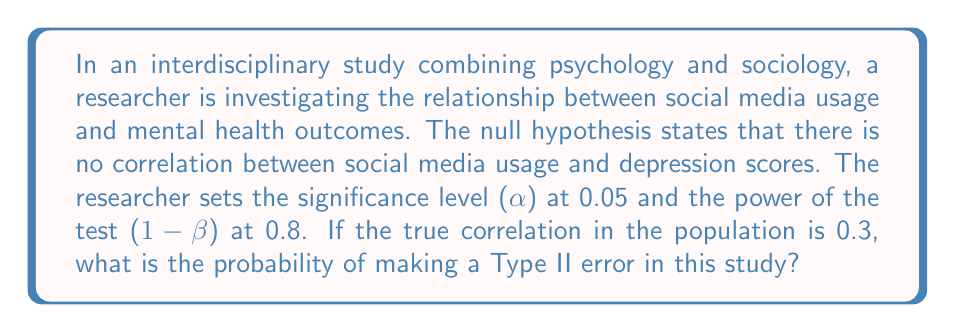Provide a solution to this math problem. To solve this problem, we need to understand the relationship between Type I error, Type II error, significance level, and power. Let's break it down step-by-step:

1. Type I error (α) is the probability of rejecting the null hypothesis when it's actually true. In this case, α = 0.05.

2. Type II error (β) is the probability of failing to reject the null hypothesis when it's actually false.

3. Power (1 - β) is the probability of correctly rejecting the null hypothesis when it's false. We're given that the power is 0.8.

4. The relationship between power and Type II error is:
   $$ \text{Power} = 1 - \beta $$

5. Given that the power is 0.8, we can calculate β:
   $$ 0.8 = 1 - \beta $$
   $$ \beta = 1 - 0.8 = 0.2 $$

6. The probability of making a Type II error is equal to β, which we just calculated as 0.2 or 20%.

Note: The actual correlation in the population (0.3) and the significance level (0.05) are not directly used in this calculation but are important for context and determining the power of the test in practice.
Answer: 0.2 